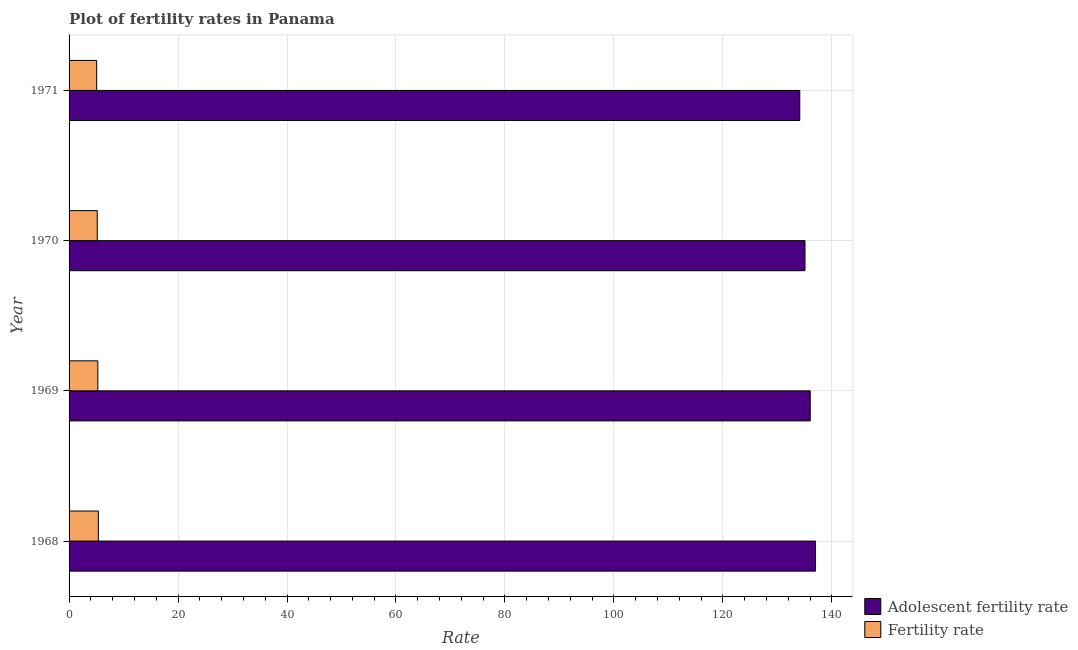How many different coloured bars are there?
Provide a succinct answer. 2. Are the number of bars per tick equal to the number of legend labels?
Keep it short and to the point. Yes. What is the label of the 3rd group of bars from the top?
Ensure brevity in your answer.  1969. What is the fertility rate in 1970?
Provide a short and direct response. 5.17. Across all years, what is the maximum fertility rate?
Give a very brief answer. 5.38. Across all years, what is the minimum adolescent fertility rate?
Offer a very short reply. 134.12. In which year was the fertility rate maximum?
Your response must be concise. 1968. In which year was the adolescent fertility rate minimum?
Provide a short and direct response. 1971. What is the total fertility rate in the graph?
Your answer should be compact. 20.89. What is the difference between the fertility rate in 1968 and that in 1969?
Offer a terse response. 0.1. What is the difference between the fertility rate in 1968 and the adolescent fertility rate in 1970?
Give a very brief answer. -129.7. What is the average fertility rate per year?
Your response must be concise. 5.22. In the year 1968, what is the difference between the adolescent fertility rate and fertility rate?
Offer a very short reply. 131.62. In how many years, is the fertility rate greater than 116 ?
Your answer should be very brief. 0. Is the fertility rate in 1968 less than that in 1970?
Your response must be concise. No. What is the difference between the highest and the second highest adolescent fertility rate?
Your answer should be compact. 0.96. What is the difference between the highest and the lowest adolescent fertility rate?
Offer a terse response. 2.88. In how many years, is the fertility rate greater than the average fertility rate taken over all years?
Provide a short and direct response. 2. What does the 1st bar from the top in 1971 represents?
Ensure brevity in your answer.  Fertility rate. What does the 1st bar from the bottom in 1969 represents?
Make the answer very short. Adolescent fertility rate. How many years are there in the graph?
Give a very brief answer. 4. What is the difference between two consecutive major ticks on the X-axis?
Your response must be concise. 20. Where does the legend appear in the graph?
Offer a very short reply. Bottom right. How many legend labels are there?
Your answer should be compact. 2. How are the legend labels stacked?
Provide a short and direct response. Vertical. What is the title of the graph?
Provide a short and direct response. Plot of fertility rates in Panama. What is the label or title of the X-axis?
Ensure brevity in your answer.  Rate. What is the label or title of the Y-axis?
Offer a very short reply. Year. What is the Rate of Adolescent fertility rate in 1968?
Give a very brief answer. 136.99. What is the Rate in Fertility rate in 1968?
Your answer should be compact. 5.38. What is the Rate in Adolescent fertility rate in 1969?
Keep it short and to the point. 136.04. What is the Rate in Fertility rate in 1969?
Keep it short and to the point. 5.28. What is the Rate in Adolescent fertility rate in 1970?
Keep it short and to the point. 135.08. What is the Rate in Fertility rate in 1970?
Offer a terse response. 5.17. What is the Rate in Adolescent fertility rate in 1971?
Your response must be concise. 134.12. What is the Rate in Fertility rate in 1971?
Your answer should be very brief. 5.06. Across all years, what is the maximum Rate in Adolescent fertility rate?
Keep it short and to the point. 136.99. Across all years, what is the maximum Rate of Fertility rate?
Offer a terse response. 5.38. Across all years, what is the minimum Rate in Adolescent fertility rate?
Your answer should be very brief. 134.12. Across all years, what is the minimum Rate in Fertility rate?
Your answer should be very brief. 5.06. What is the total Rate of Adolescent fertility rate in the graph?
Give a very brief answer. 542.22. What is the total Rate in Fertility rate in the graph?
Keep it short and to the point. 20.89. What is the difference between the Rate in Adolescent fertility rate in 1968 and that in 1969?
Give a very brief answer. 0.96. What is the difference between the Rate in Fertility rate in 1968 and that in 1969?
Keep it short and to the point. 0.1. What is the difference between the Rate of Adolescent fertility rate in 1968 and that in 1970?
Offer a very short reply. 1.92. What is the difference between the Rate in Fertility rate in 1968 and that in 1970?
Offer a terse response. 0.2. What is the difference between the Rate in Adolescent fertility rate in 1968 and that in 1971?
Make the answer very short. 2.88. What is the difference between the Rate of Fertility rate in 1968 and that in 1971?
Offer a terse response. 0.32. What is the difference between the Rate in Adolescent fertility rate in 1969 and that in 1970?
Make the answer very short. 0.96. What is the difference between the Rate of Fertility rate in 1969 and that in 1970?
Offer a very short reply. 0.11. What is the difference between the Rate in Adolescent fertility rate in 1969 and that in 1971?
Ensure brevity in your answer.  1.92. What is the difference between the Rate in Fertility rate in 1969 and that in 1971?
Your answer should be compact. 0.22. What is the difference between the Rate in Adolescent fertility rate in 1970 and that in 1971?
Offer a very short reply. 0.96. What is the difference between the Rate in Fertility rate in 1970 and that in 1971?
Your response must be concise. 0.11. What is the difference between the Rate of Adolescent fertility rate in 1968 and the Rate of Fertility rate in 1969?
Provide a succinct answer. 131.72. What is the difference between the Rate in Adolescent fertility rate in 1968 and the Rate in Fertility rate in 1970?
Offer a terse response. 131.82. What is the difference between the Rate of Adolescent fertility rate in 1968 and the Rate of Fertility rate in 1971?
Make the answer very short. 131.93. What is the difference between the Rate in Adolescent fertility rate in 1969 and the Rate in Fertility rate in 1970?
Your answer should be compact. 130.86. What is the difference between the Rate of Adolescent fertility rate in 1969 and the Rate of Fertility rate in 1971?
Provide a succinct answer. 130.98. What is the difference between the Rate in Adolescent fertility rate in 1970 and the Rate in Fertility rate in 1971?
Give a very brief answer. 130.02. What is the average Rate of Adolescent fertility rate per year?
Provide a short and direct response. 135.56. What is the average Rate of Fertility rate per year?
Make the answer very short. 5.22. In the year 1968, what is the difference between the Rate of Adolescent fertility rate and Rate of Fertility rate?
Offer a terse response. 131.62. In the year 1969, what is the difference between the Rate of Adolescent fertility rate and Rate of Fertility rate?
Keep it short and to the point. 130.76. In the year 1970, what is the difference between the Rate of Adolescent fertility rate and Rate of Fertility rate?
Provide a succinct answer. 129.9. In the year 1971, what is the difference between the Rate of Adolescent fertility rate and Rate of Fertility rate?
Ensure brevity in your answer.  129.06. What is the ratio of the Rate in Adolescent fertility rate in 1968 to that in 1969?
Ensure brevity in your answer.  1.01. What is the ratio of the Rate of Fertility rate in 1968 to that in 1969?
Make the answer very short. 1.02. What is the ratio of the Rate in Adolescent fertility rate in 1968 to that in 1970?
Your answer should be very brief. 1.01. What is the ratio of the Rate of Fertility rate in 1968 to that in 1970?
Give a very brief answer. 1.04. What is the ratio of the Rate in Adolescent fertility rate in 1968 to that in 1971?
Your answer should be very brief. 1.02. What is the ratio of the Rate in Fertility rate in 1968 to that in 1971?
Ensure brevity in your answer.  1.06. What is the ratio of the Rate of Adolescent fertility rate in 1969 to that in 1970?
Your answer should be very brief. 1.01. What is the ratio of the Rate in Fertility rate in 1969 to that in 1970?
Your answer should be very brief. 1.02. What is the ratio of the Rate of Adolescent fertility rate in 1969 to that in 1971?
Your answer should be compact. 1.01. What is the ratio of the Rate in Fertility rate in 1969 to that in 1971?
Provide a short and direct response. 1.04. What is the ratio of the Rate of Adolescent fertility rate in 1970 to that in 1971?
Ensure brevity in your answer.  1.01. What is the ratio of the Rate in Fertility rate in 1970 to that in 1971?
Your answer should be compact. 1.02. What is the difference between the highest and the second highest Rate of Adolescent fertility rate?
Keep it short and to the point. 0.96. What is the difference between the highest and the second highest Rate of Fertility rate?
Ensure brevity in your answer.  0.1. What is the difference between the highest and the lowest Rate in Adolescent fertility rate?
Provide a succinct answer. 2.88. What is the difference between the highest and the lowest Rate of Fertility rate?
Ensure brevity in your answer.  0.32. 